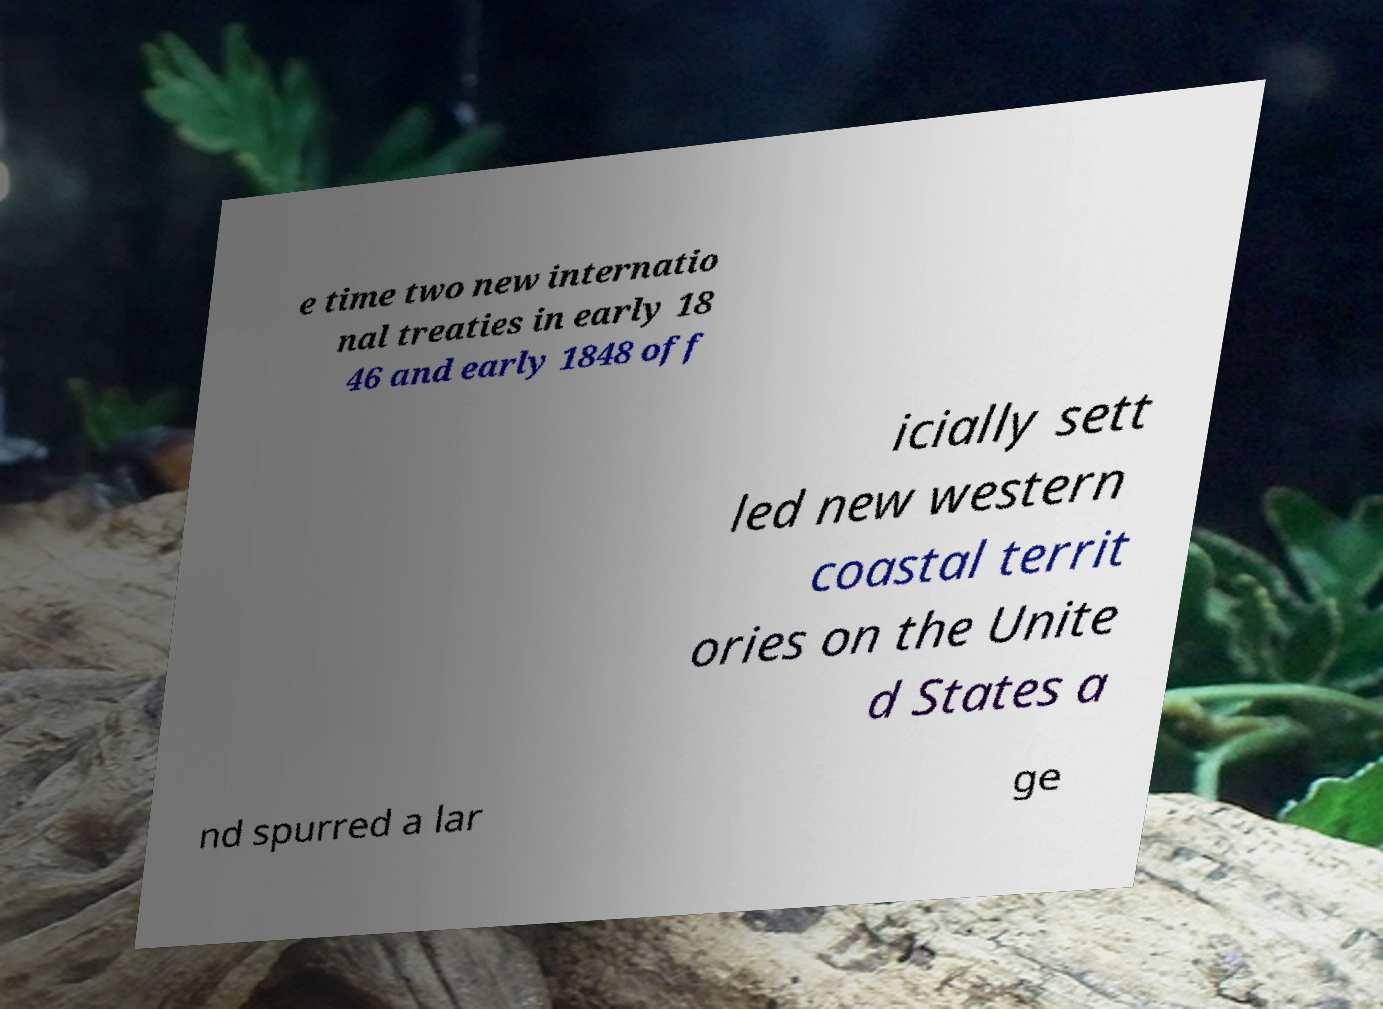Please identify and transcribe the text found in this image. e time two new internatio nal treaties in early 18 46 and early 1848 off icially sett led new western coastal territ ories on the Unite d States a nd spurred a lar ge 